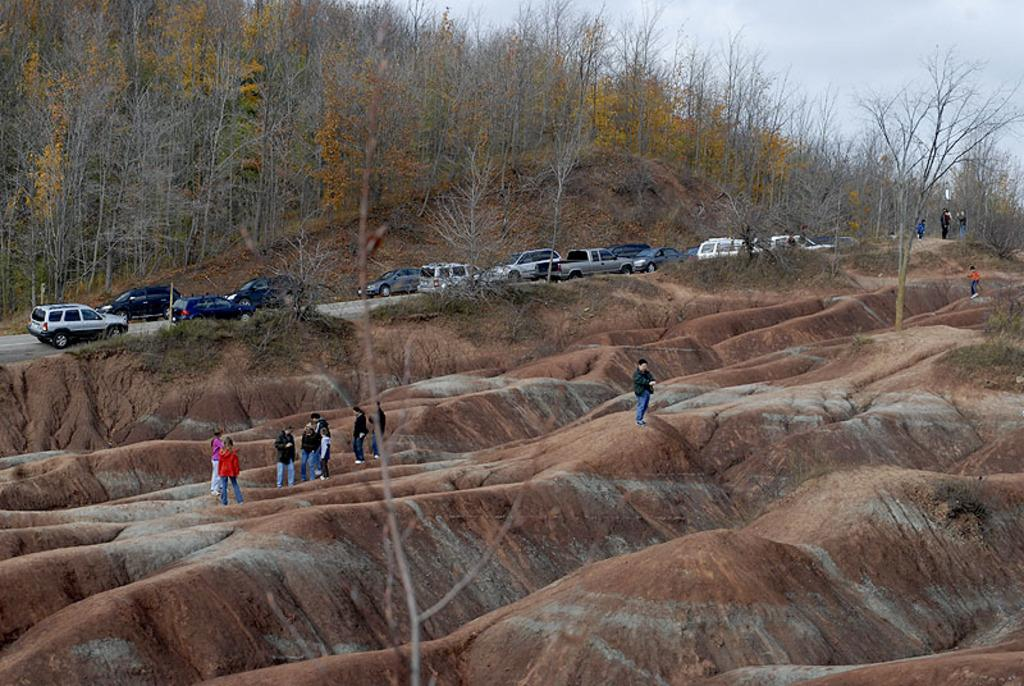What are the people in the image doing? The people in the image are standing on the ground. What can be seen in the background of the image? Vehicles, trees, the sky, and other objects are visible in the background of the image. Can you describe the road in the background? The road is where the vehicles are visible in the background. What is the condition of the sky in the image? The sky is visible in the background of the image. What type of beef is being cooked on the pot in the image? There is no pot or beef present in the image. What is the friction between the people and the ground in the image? There is no mention of friction between the people and the ground in the image. 